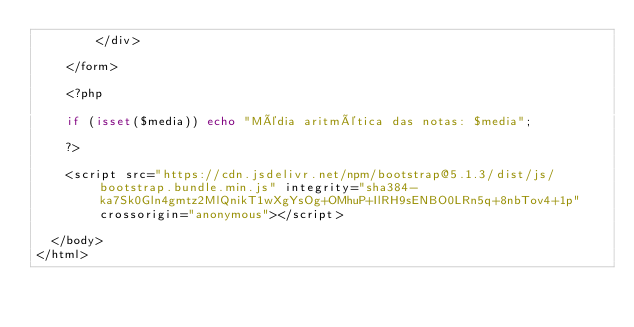Convert code to text. <code><loc_0><loc_0><loc_500><loc_500><_PHP_>        </div>

    </form>
    
    <?php

    if (isset($media)) echo "Média aritmética das notas: $media";

    ?>

    <script src="https://cdn.jsdelivr.net/npm/bootstrap@5.1.3/dist/js/bootstrap.bundle.min.js" integrity="sha384-ka7Sk0Gln4gmtz2MlQnikT1wXgYsOg+OMhuP+IlRH9sENBO0LRn5q+8nbTov4+1p" crossorigin="anonymous"></script>

  </body>
</html></code> 